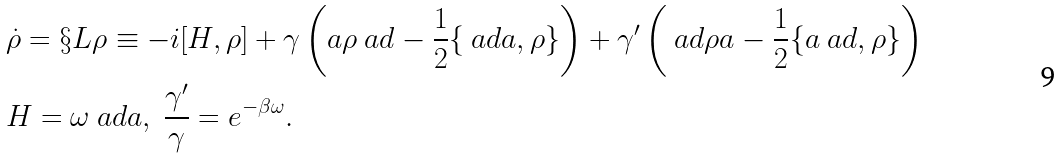Convert formula to latex. <formula><loc_0><loc_0><loc_500><loc_500>& \dot { \rho } = \S L \rho \equiv - i [ H , \rho ] + \gamma \left ( a \rho \ a d - \frac { 1 } { 2 } \{ \ a d a , \rho \} \right ) + \gamma ^ { \prime } \left ( \ a d \rho a - \frac { 1 } { 2 } \{ a \ a d , \rho \} \right ) \\ & H = \omega \ a d a , \ \frac { \gamma ^ { \prime } } { \gamma } = e ^ { - \beta \omega } .</formula> 